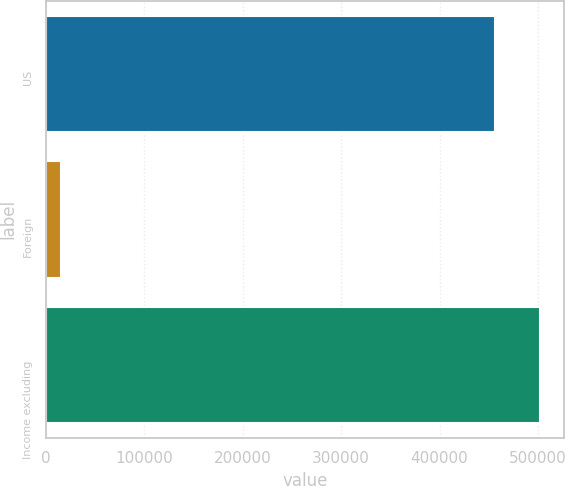Convert chart. <chart><loc_0><loc_0><loc_500><loc_500><bar_chart><fcel>US<fcel>Foreign<fcel>Income excluding<nl><fcel>456175<fcel>15350<fcel>501792<nl></chart> 